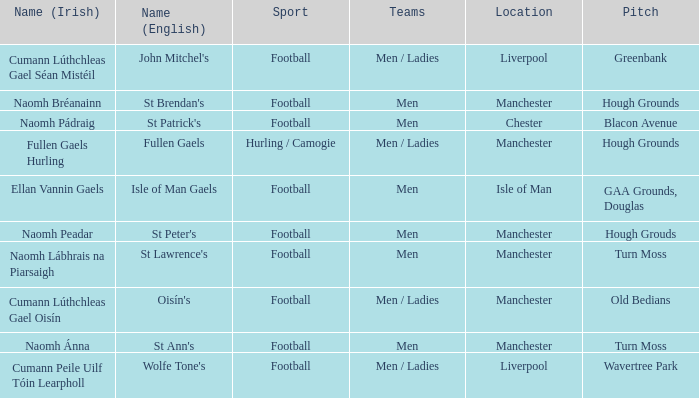What Pitch is located at Isle of Man? GAA Grounds, Douglas. 